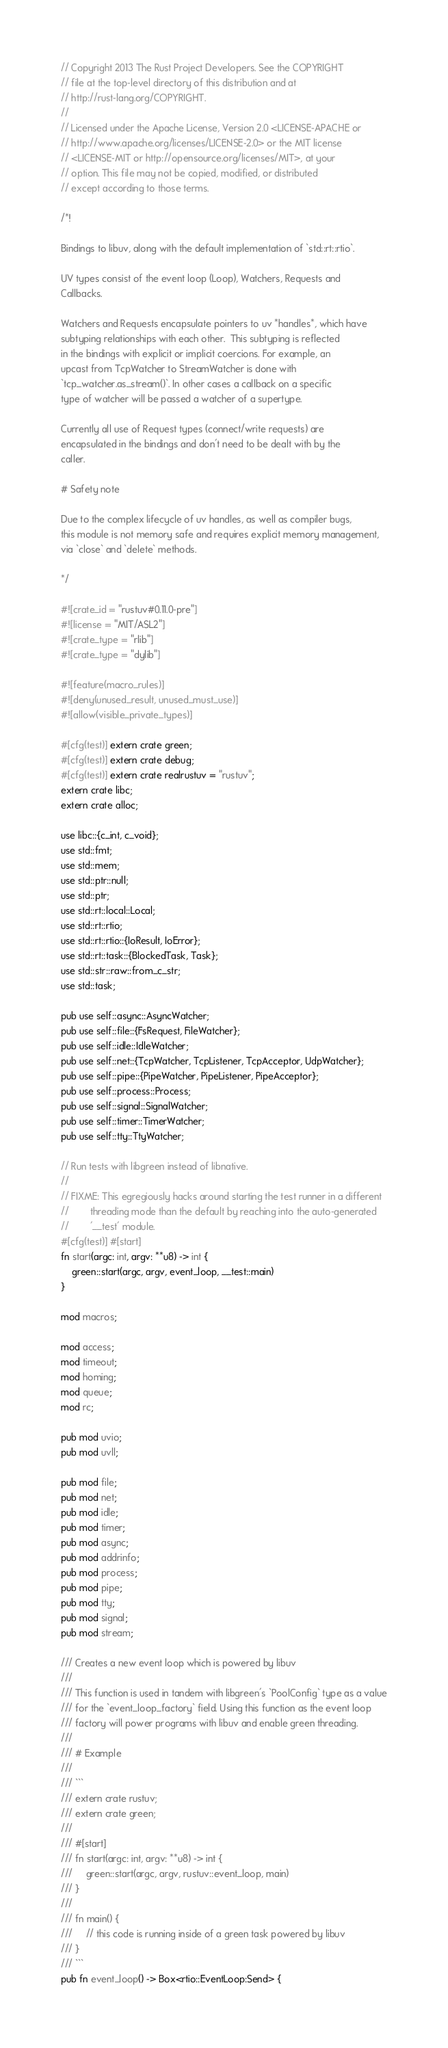Convert code to text. <code><loc_0><loc_0><loc_500><loc_500><_Rust_>// Copyright 2013 The Rust Project Developers. See the COPYRIGHT
// file at the top-level directory of this distribution and at
// http://rust-lang.org/COPYRIGHT.
//
// Licensed under the Apache License, Version 2.0 <LICENSE-APACHE or
// http://www.apache.org/licenses/LICENSE-2.0> or the MIT license
// <LICENSE-MIT or http://opensource.org/licenses/MIT>, at your
// option. This file may not be copied, modified, or distributed
// except according to those terms.

/*!

Bindings to libuv, along with the default implementation of `std::rt::rtio`.

UV types consist of the event loop (Loop), Watchers, Requests and
Callbacks.

Watchers and Requests encapsulate pointers to uv *handles*, which have
subtyping relationships with each other.  This subtyping is reflected
in the bindings with explicit or implicit coercions. For example, an
upcast from TcpWatcher to StreamWatcher is done with
`tcp_watcher.as_stream()`. In other cases a callback on a specific
type of watcher will be passed a watcher of a supertype.

Currently all use of Request types (connect/write requests) are
encapsulated in the bindings and don't need to be dealt with by the
caller.

# Safety note

Due to the complex lifecycle of uv handles, as well as compiler bugs,
this module is not memory safe and requires explicit memory management,
via `close` and `delete` methods.

*/

#![crate_id = "rustuv#0.11.0-pre"]
#![license = "MIT/ASL2"]
#![crate_type = "rlib"]
#![crate_type = "dylib"]

#![feature(macro_rules)]
#![deny(unused_result, unused_must_use)]
#![allow(visible_private_types)]

#[cfg(test)] extern crate green;
#[cfg(test)] extern crate debug;
#[cfg(test)] extern crate realrustuv = "rustuv";
extern crate libc;
extern crate alloc;

use libc::{c_int, c_void};
use std::fmt;
use std::mem;
use std::ptr::null;
use std::ptr;
use std::rt::local::Local;
use std::rt::rtio;
use std::rt::rtio::{IoResult, IoError};
use std::rt::task::{BlockedTask, Task};
use std::str::raw::from_c_str;
use std::task;

pub use self::async::AsyncWatcher;
pub use self::file::{FsRequest, FileWatcher};
pub use self::idle::IdleWatcher;
pub use self::net::{TcpWatcher, TcpListener, TcpAcceptor, UdpWatcher};
pub use self::pipe::{PipeWatcher, PipeListener, PipeAcceptor};
pub use self::process::Process;
pub use self::signal::SignalWatcher;
pub use self::timer::TimerWatcher;
pub use self::tty::TtyWatcher;

// Run tests with libgreen instead of libnative.
//
// FIXME: This egregiously hacks around starting the test runner in a different
//        threading mode than the default by reaching into the auto-generated
//        '__test' module.
#[cfg(test)] #[start]
fn start(argc: int, argv: **u8) -> int {
    green::start(argc, argv, event_loop, __test::main)
}

mod macros;

mod access;
mod timeout;
mod homing;
mod queue;
mod rc;

pub mod uvio;
pub mod uvll;

pub mod file;
pub mod net;
pub mod idle;
pub mod timer;
pub mod async;
pub mod addrinfo;
pub mod process;
pub mod pipe;
pub mod tty;
pub mod signal;
pub mod stream;

/// Creates a new event loop which is powered by libuv
///
/// This function is used in tandem with libgreen's `PoolConfig` type as a value
/// for the `event_loop_factory` field. Using this function as the event loop
/// factory will power programs with libuv and enable green threading.
///
/// # Example
///
/// ```
/// extern crate rustuv;
/// extern crate green;
///
/// #[start]
/// fn start(argc: int, argv: **u8) -> int {
///     green::start(argc, argv, rustuv::event_loop, main)
/// }
///
/// fn main() {
///     // this code is running inside of a green task powered by libuv
/// }
/// ```
pub fn event_loop() -> Box<rtio::EventLoop:Send> {</code> 